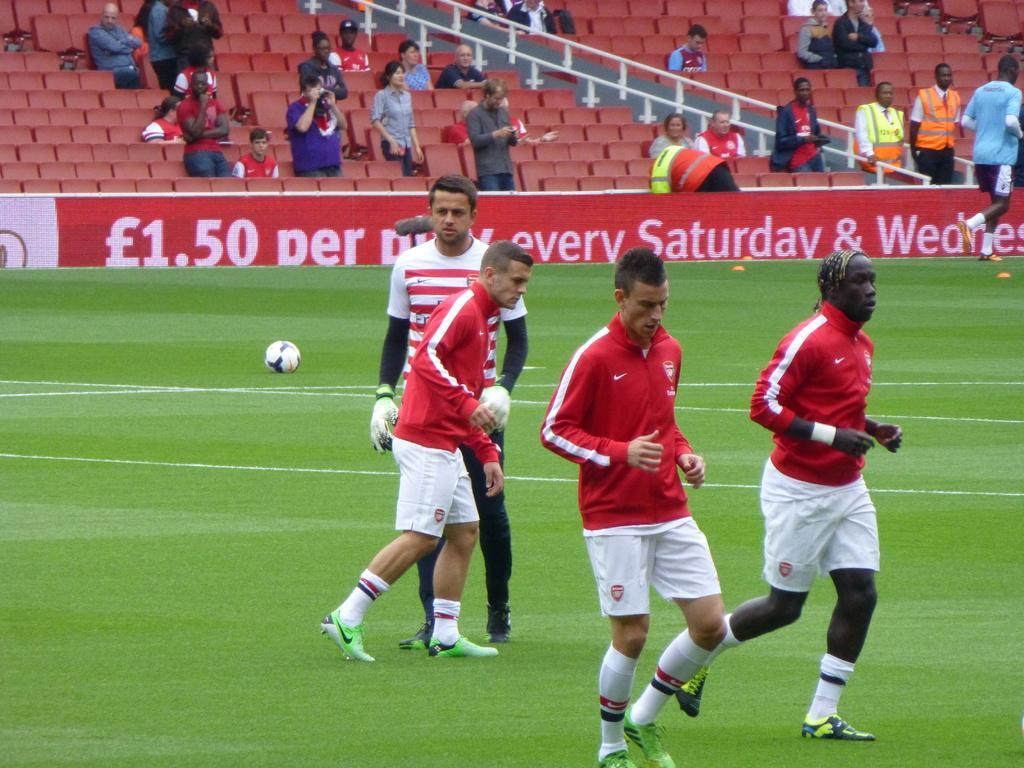<image>
Create a compact narrative representing the image presented. Soccer players play on a field in front of an advert for a Saturday and Wednesday special. 